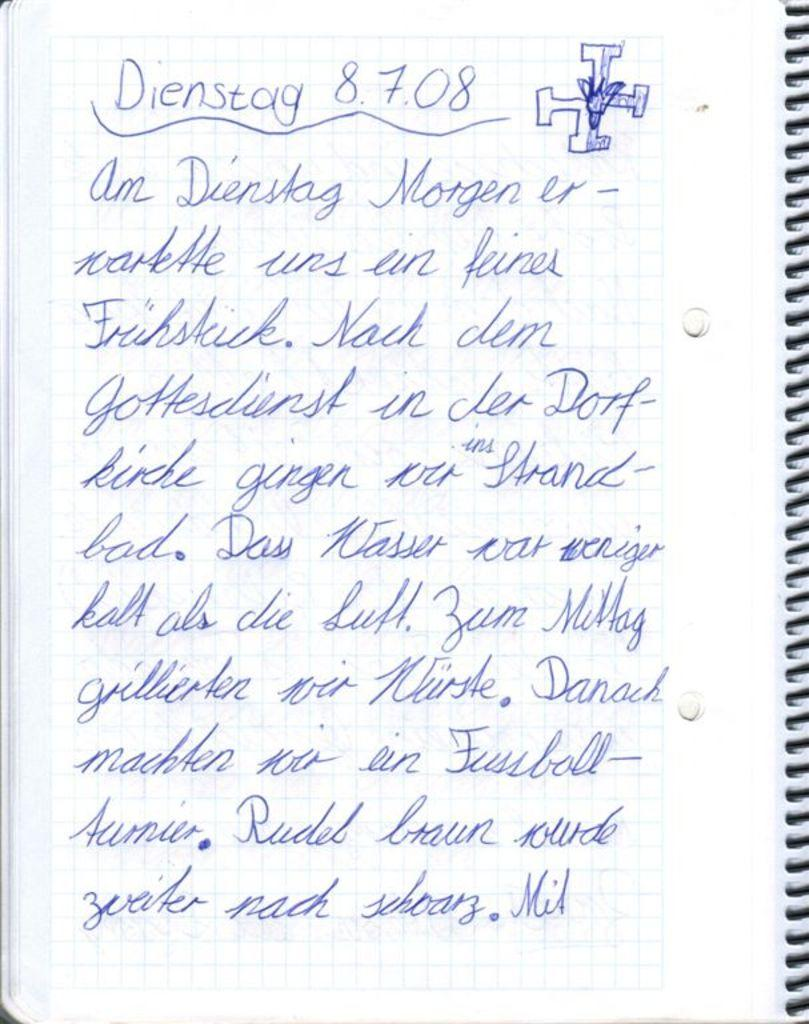What object is present in the image? There is a book in the image. What is inside the book? The book has papers in it. Can you describe the content of the papers? There is text written on the papers. What type of event is taking place in the park in the image? There is no park or event present in the image; it only features a book with papers inside. Can you see the moon in the image? There is no moon visible in the image. 